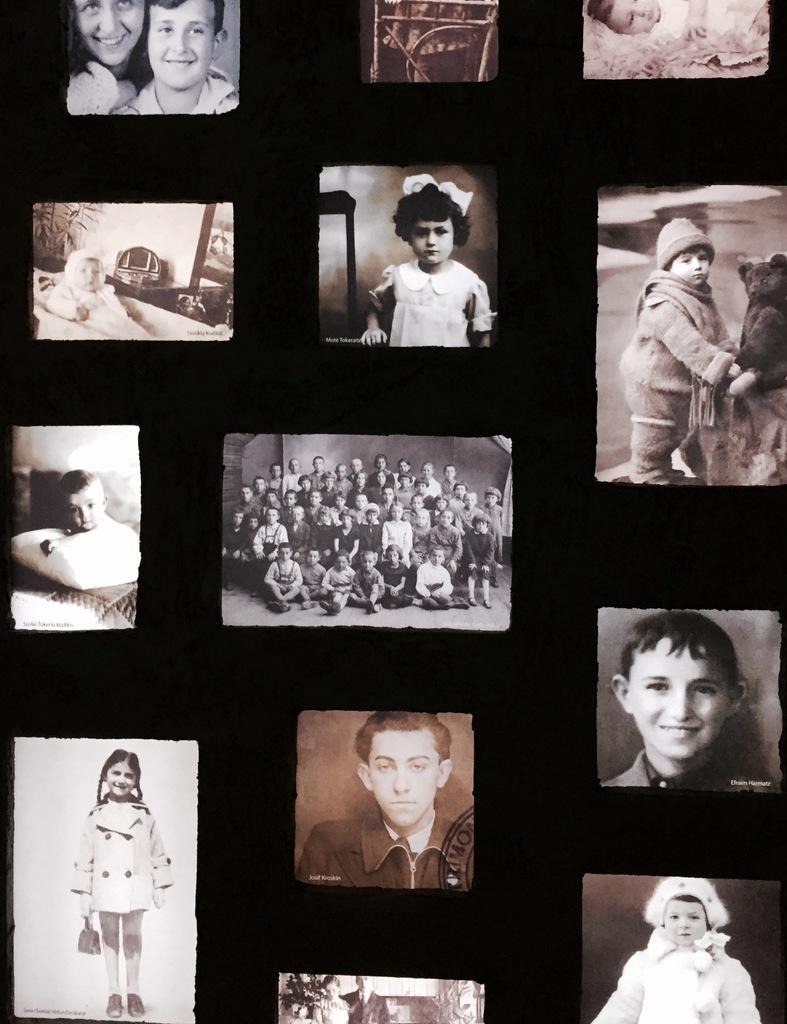What type of images are present in the picture? There are photos of people in the image. Can you describe the subjects of the photos? Some of the photos contain kids, while others contain a group of people or babies. What is the level of anger expressed by the people in the photos? There is no indication of anger in the photos; they simply depict people, kids, groups, and babies. 